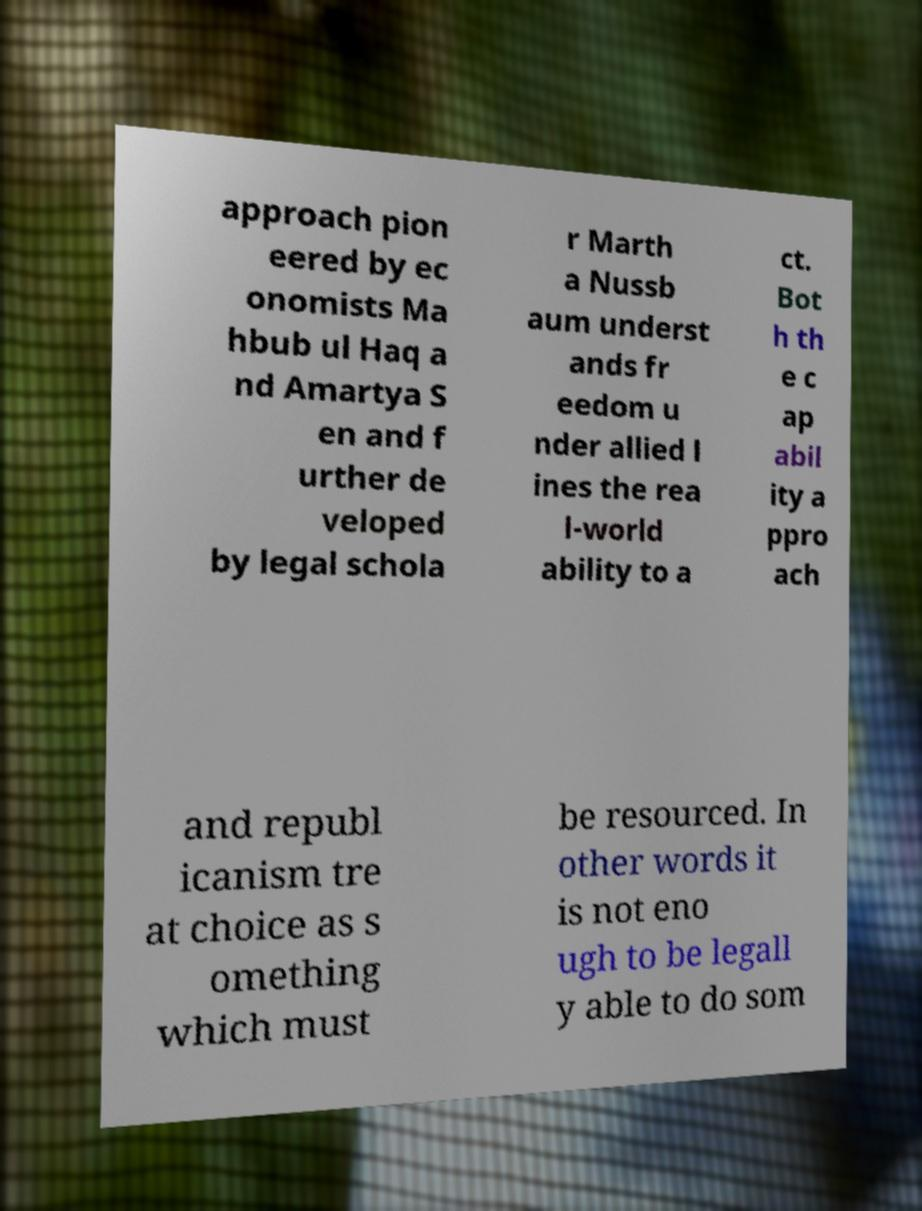What messages or text are displayed in this image? I need them in a readable, typed format. approach pion eered by ec onomists Ma hbub ul Haq a nd Amartya S en and f urther de veloped by legal schola r Marth a Nussb aum underst ands fr eedom u nder allied l ines the rea l-world ability to a ct. Bot h th e c ap abil ity a ppro ach and republ icanism tre at choice as s omething which must be resourced. In other words it is not eno ugh to be legall y able to do som 